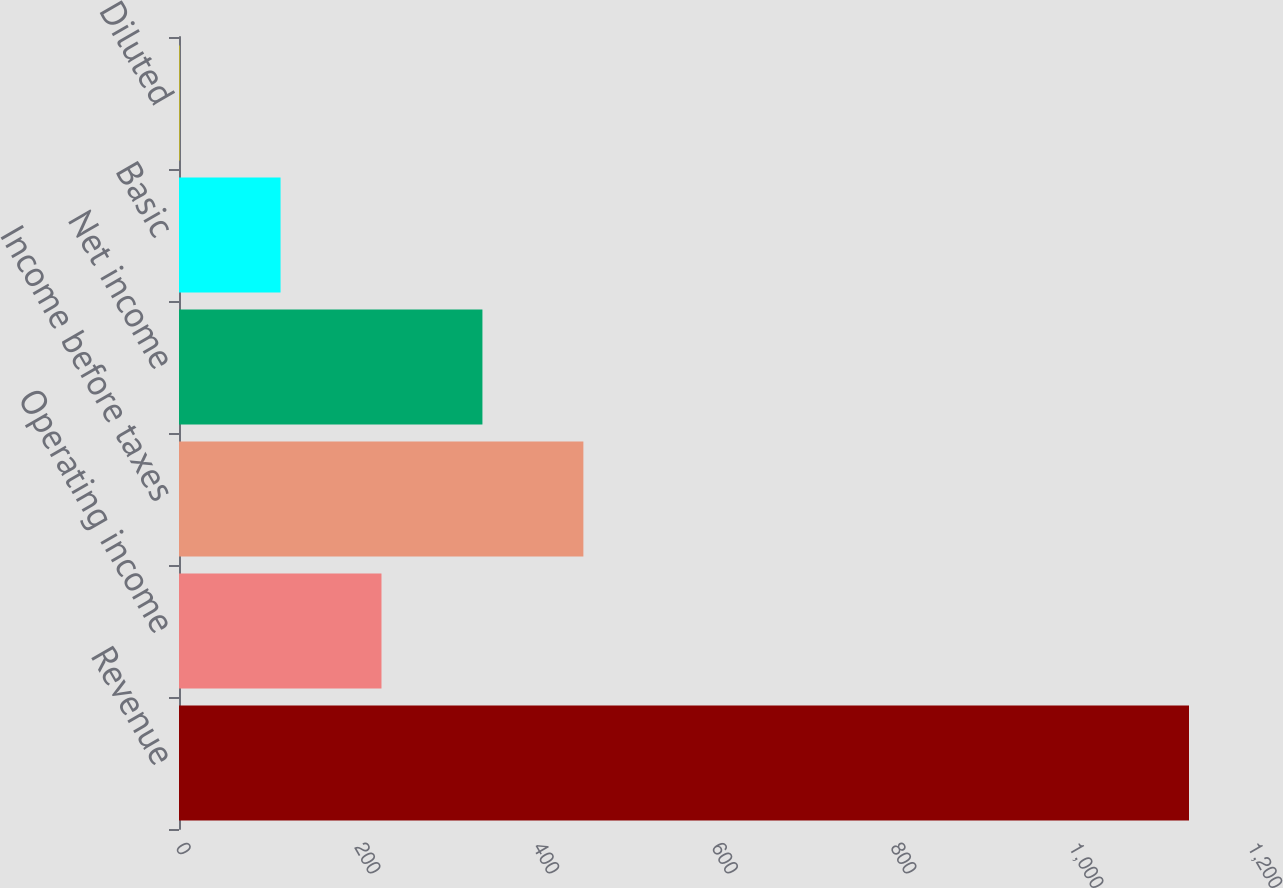<chart> <loc_0><loc_0><loc_500><loc_500><bar_chart><fcel>Revenue<fcel>Operating income<fcel>Income before taxes<fcel>Net income<fcel>Basic<fcel>Diluted<nl><fcel>1130.6<fcel>226.67<fcel>452.65<fcel>339.66<fcel>113.68<fcel>0.69<nl></chart> 